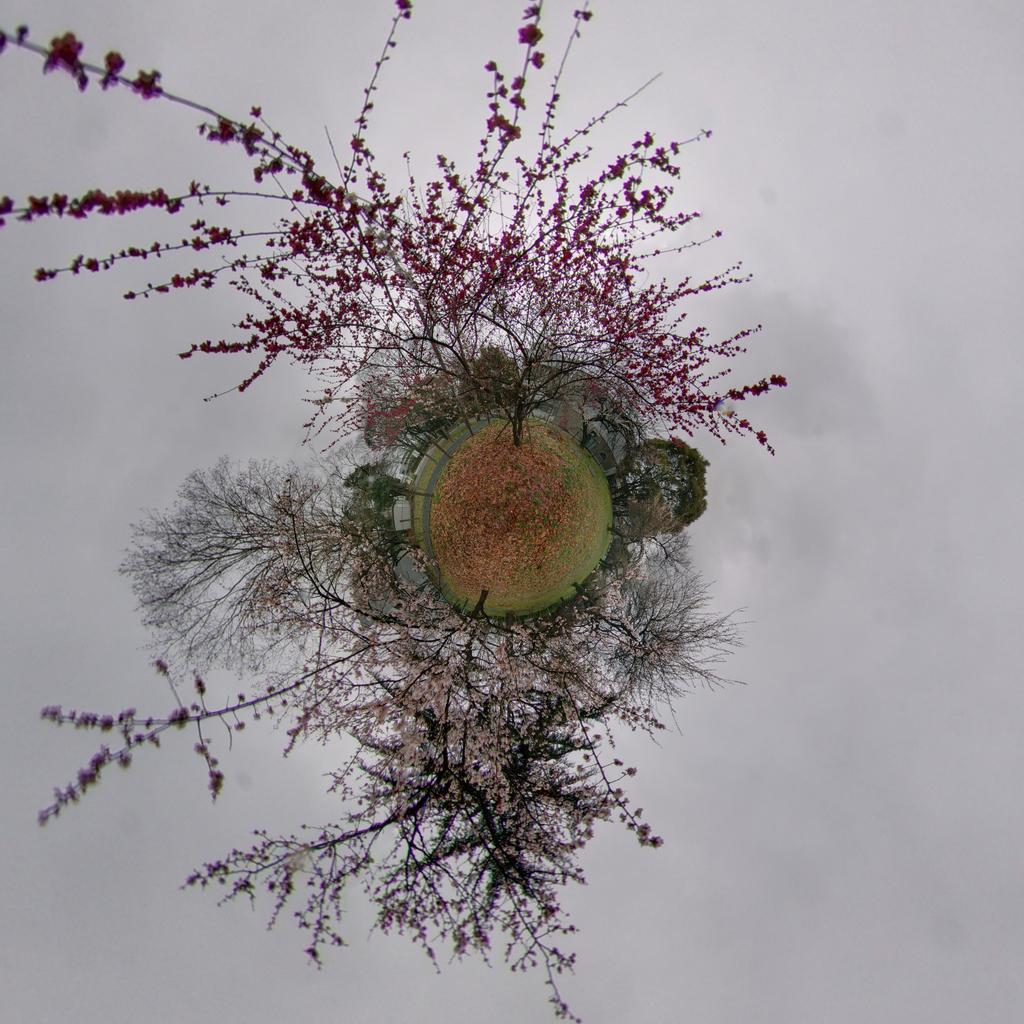Please provide a concise description of this image. In this image there are flowers on plants and trees. 